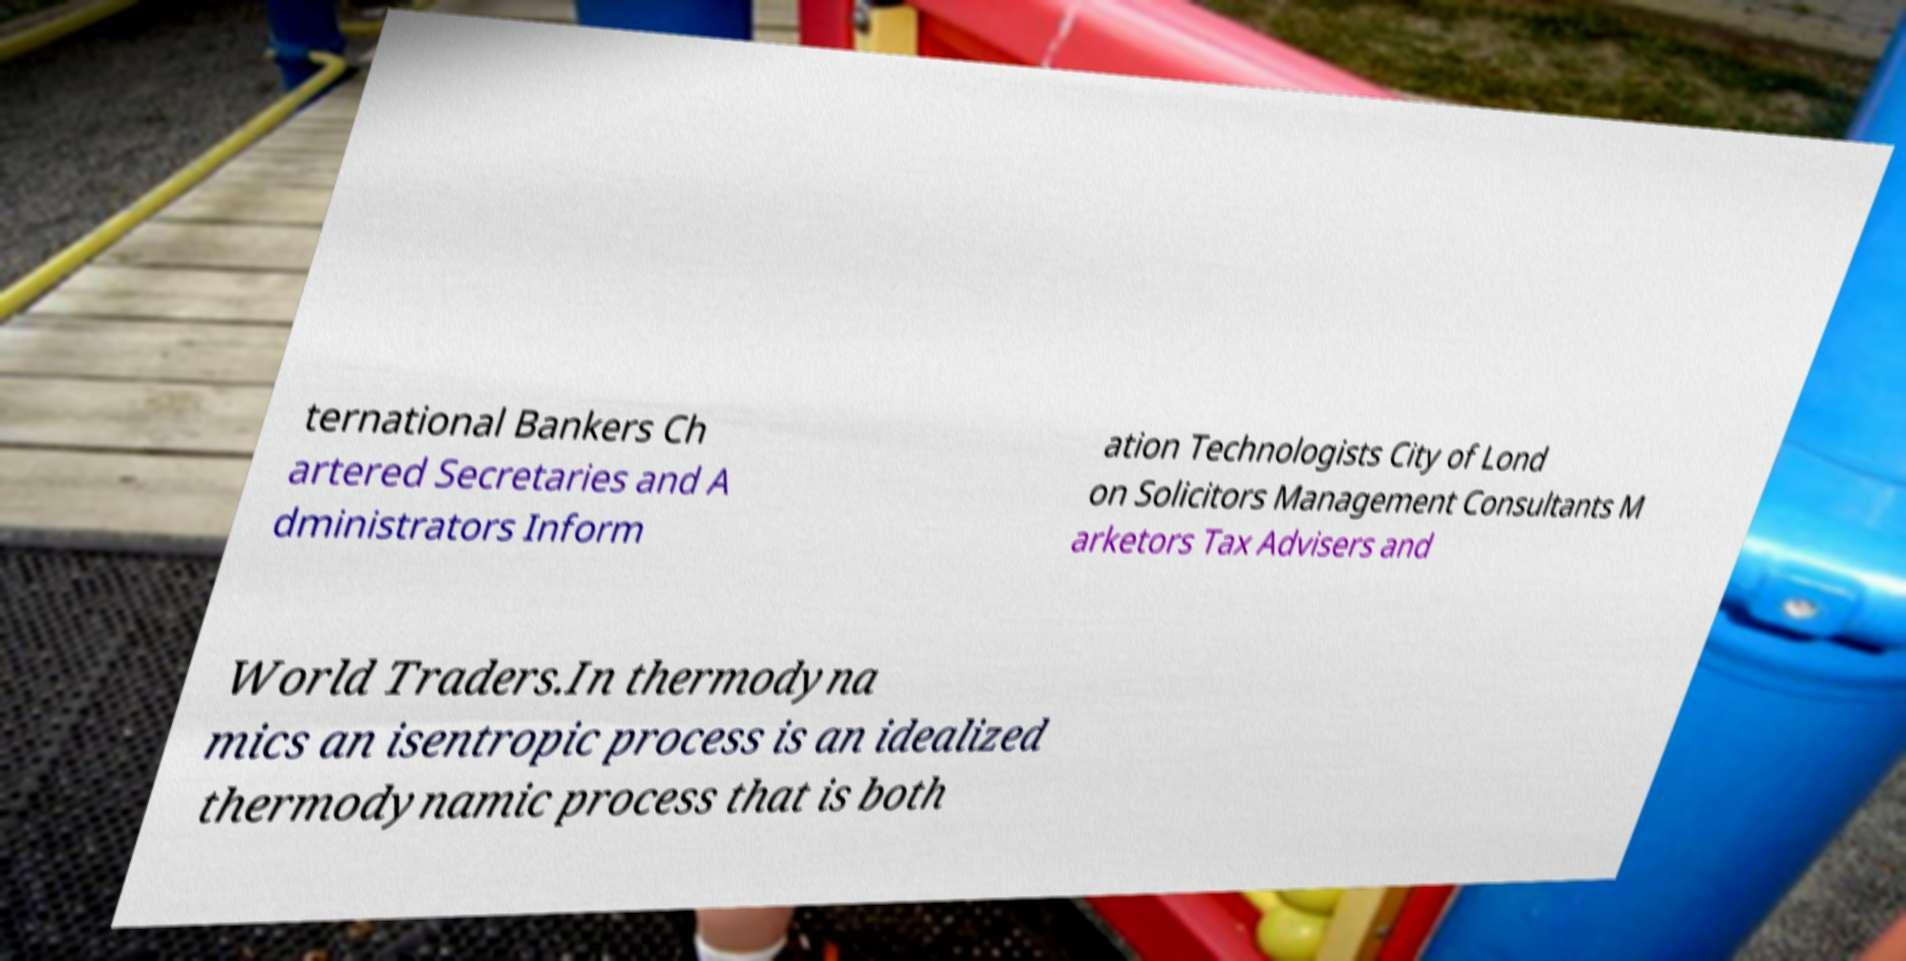Please read and relay the text visible in this image. What does it say? ternational Bankers Ch artered Secretaries and A dministrators Inform ation Technologists City of Lond on Solicitors Management Consultants M arketors Tax Advisers and World Traders.In thermodyna mics an isentropic process is an idealized thermodynamic process that is both 